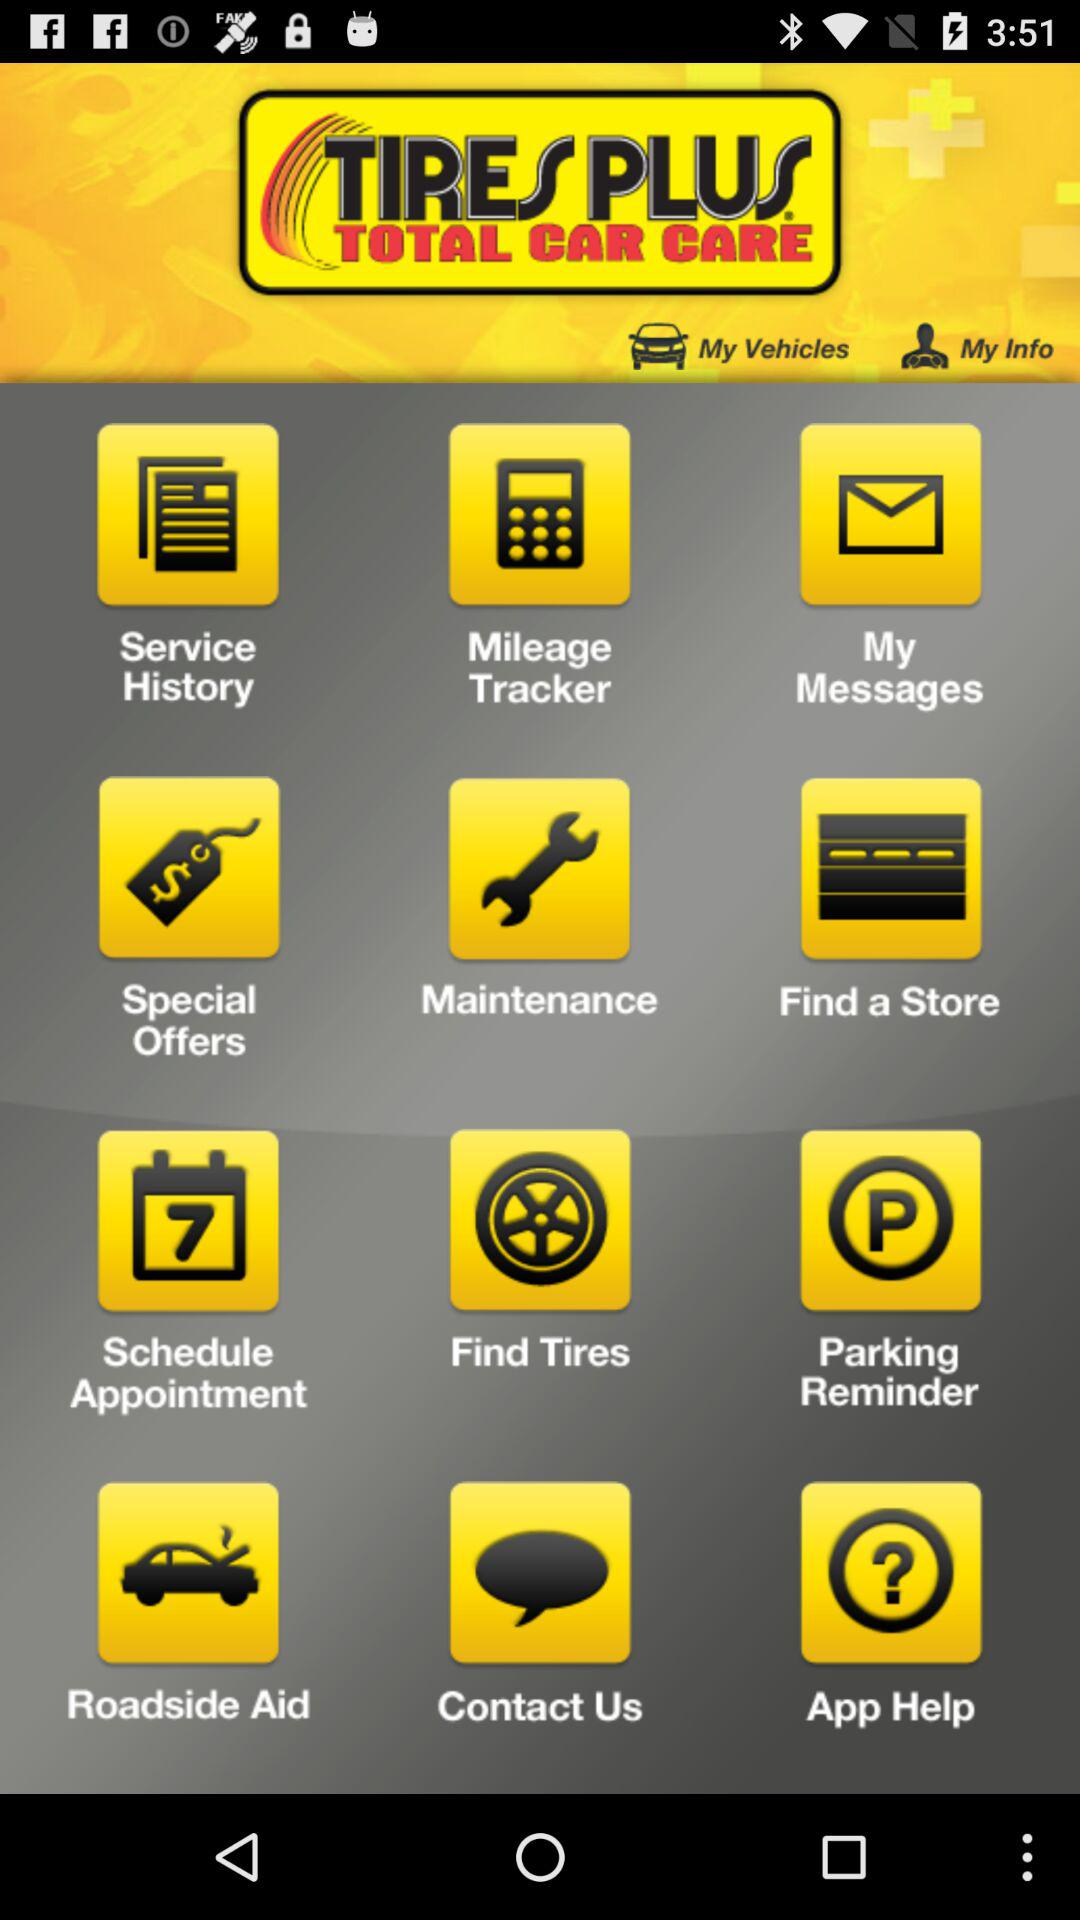What is the name of the application? The name of the application is "TIRES PLUS". 